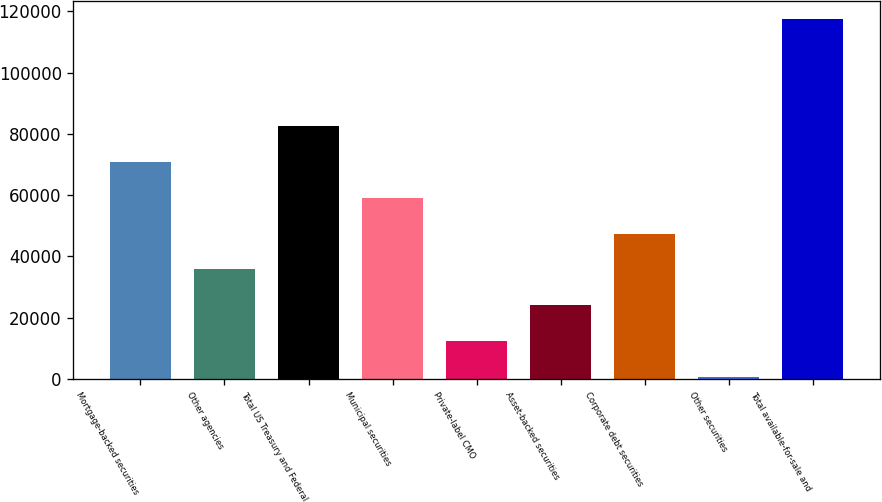Convert chart to OTSL. <chart><loc_0><loc_0><loc_500><loc_500><bar_chart><fcel>Mortgage-backed securities<fcel>Other agencies<fcel>Total US Treasury and Federal<fcel>Municipal securities<fcel>Private-label CMO<fcel>Asset-backed securities<fcel>Corporate debt securities<fcel>Other securities<fcel>Total available-for-sale and<nl><fcel>70829.6<fcel>35786.3<fcel>82510.7<fcel>59148.5<fcel>12424.1<fcel>24105.2<fcel>47467.4<fcel>743<fcel>117554<nl></chart> 